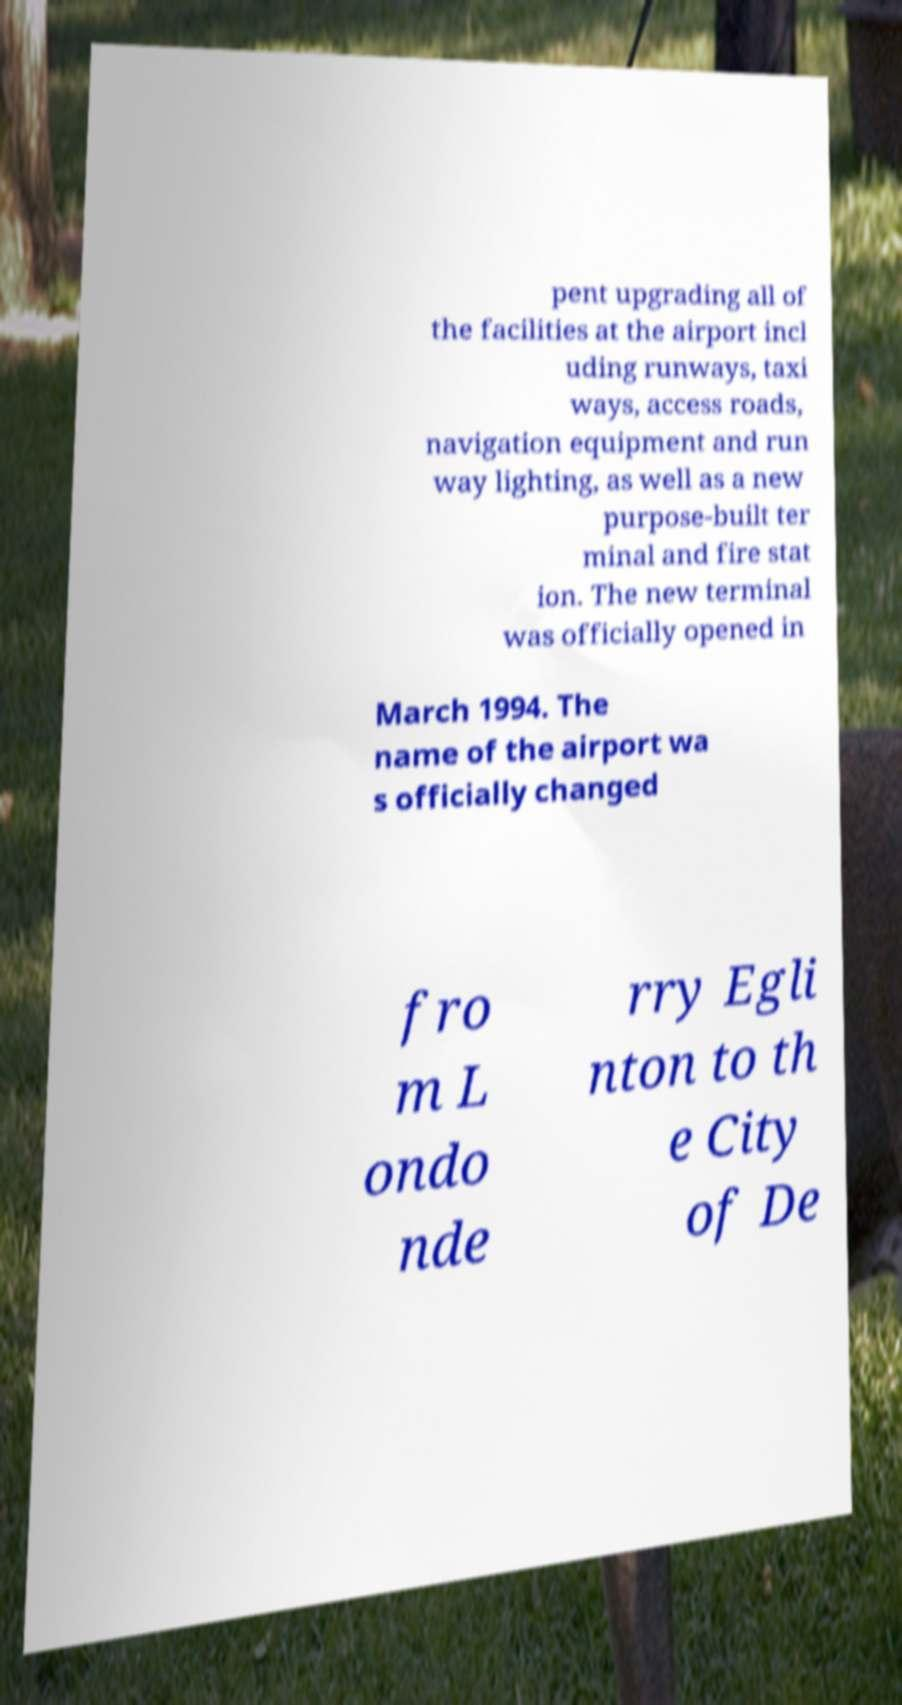Please read and relay the text visible in this image. What does it say? pent upgrading all of the facilities at the airport incl uding runways, taxi ways, access roads, navigation equipment and run way lighting, as well as a new purpose-built ter minal and fire stat ion. The new terminal was officially opened in March 1994. The name of the airport wa s officially changed fro m L ondo nde rry Egli nton to th e City of De 